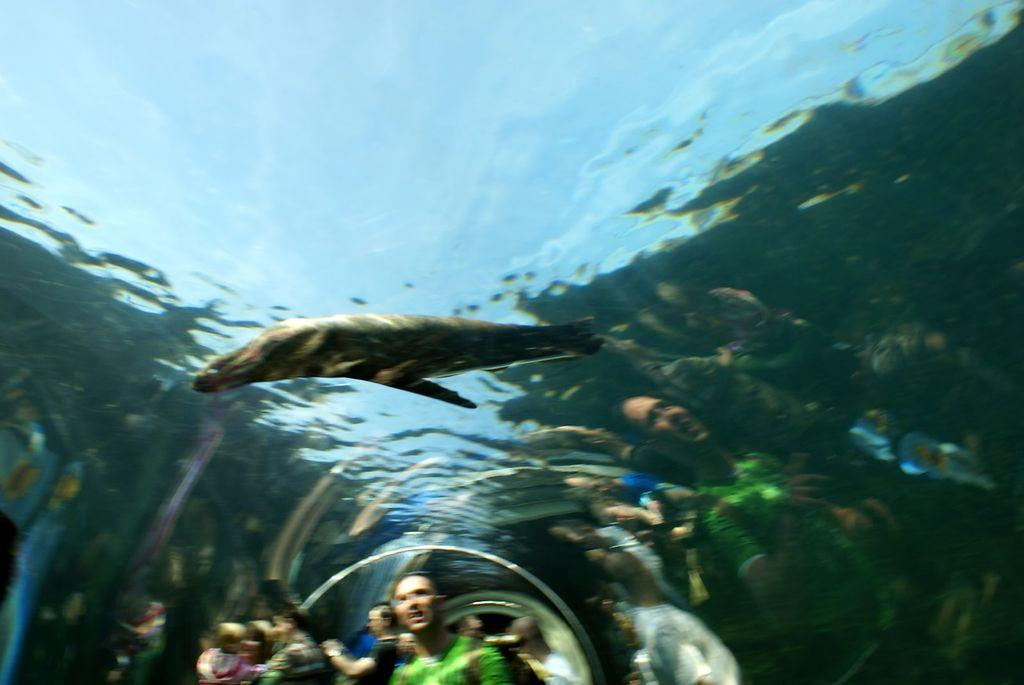What type of animal can be seen in the water in the image? There is a fish in the water in the image. Who else is present in the image besides the fish? There are people in the image. Where are the people located in relation to the water? The people are in an underground water path. How clear is the image? The image is slightly blurred. What type of payment method is accepted at the structure in the image? There is no structure present in the image, so no payment method can be determined. 